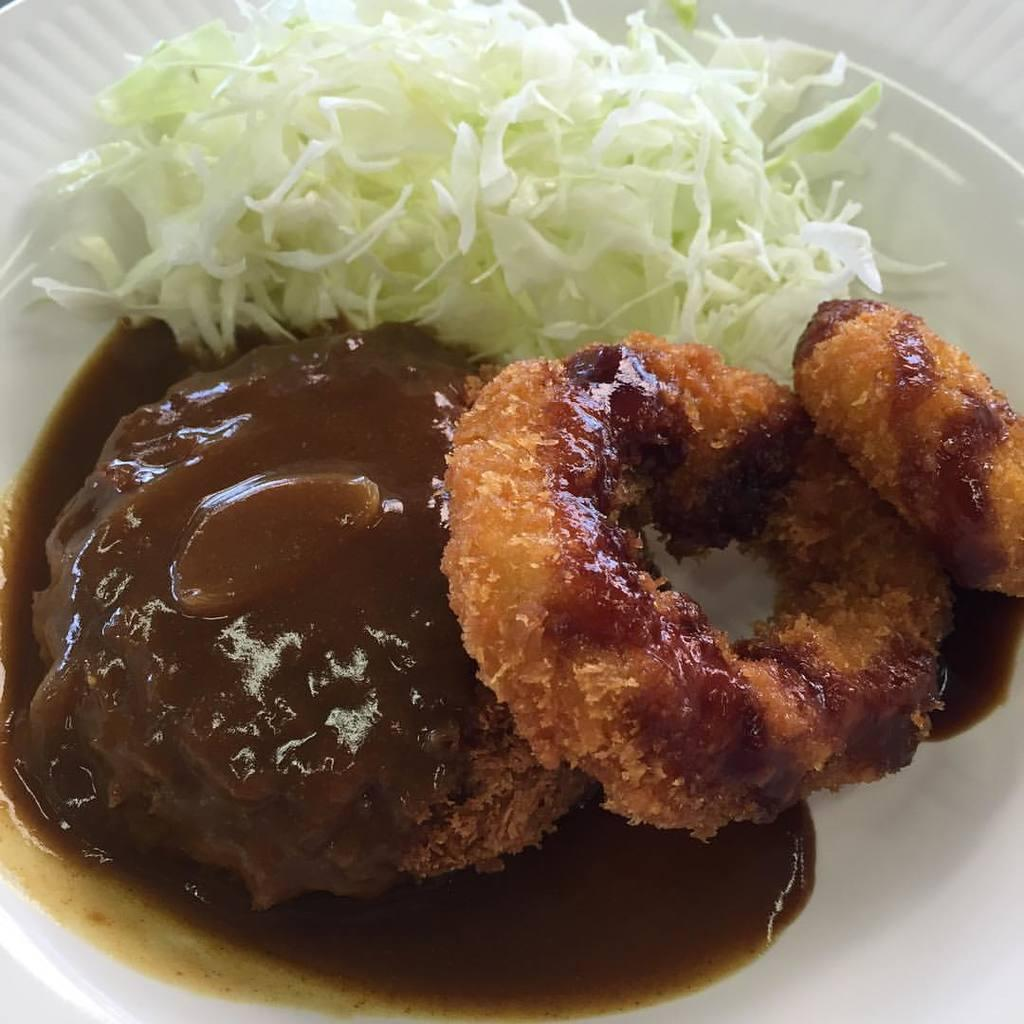What is present on the plate in the image? There are food items on a plate in the image. Can you tell me how many spots are on the berries in the image? There are no berries present in the image. 